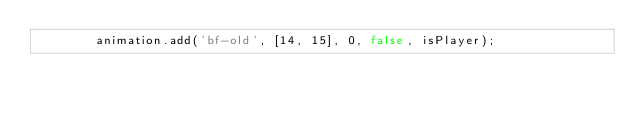<code> <loc_0><loc_0><loc_500><loc_500><_Haxe_>		animation.add('bf-old', [14, 15], 0, false, isPlayer);</code> 